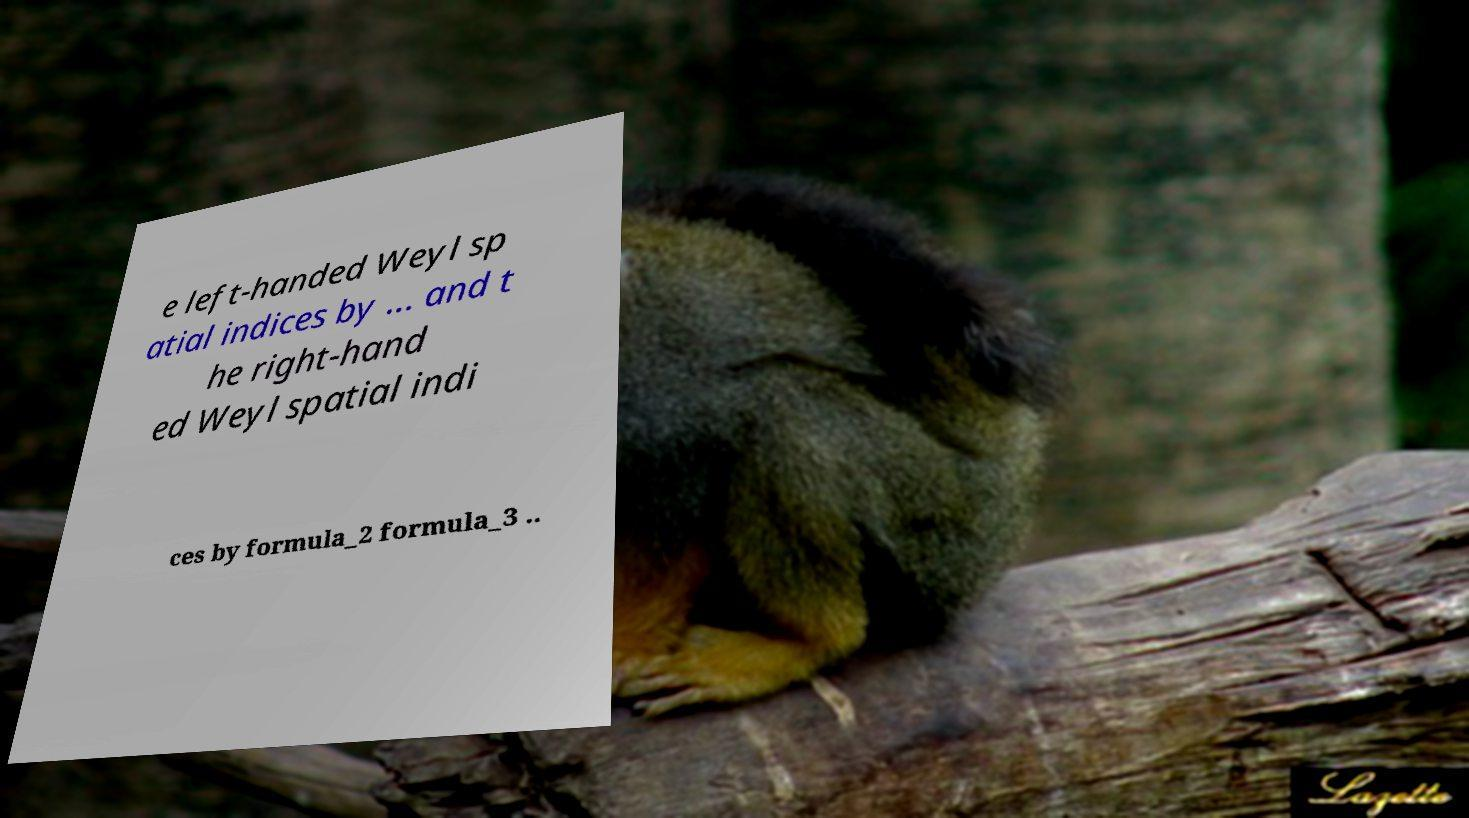Can you read and provide the text displayed in the image?This photo seems to have some interesting text. Can you extract and type it out for me? e left-handed Weyl sp atial indices by ... and t he right-hand ed Weyl spatial indi ces by formula_2 formula_3 .. 